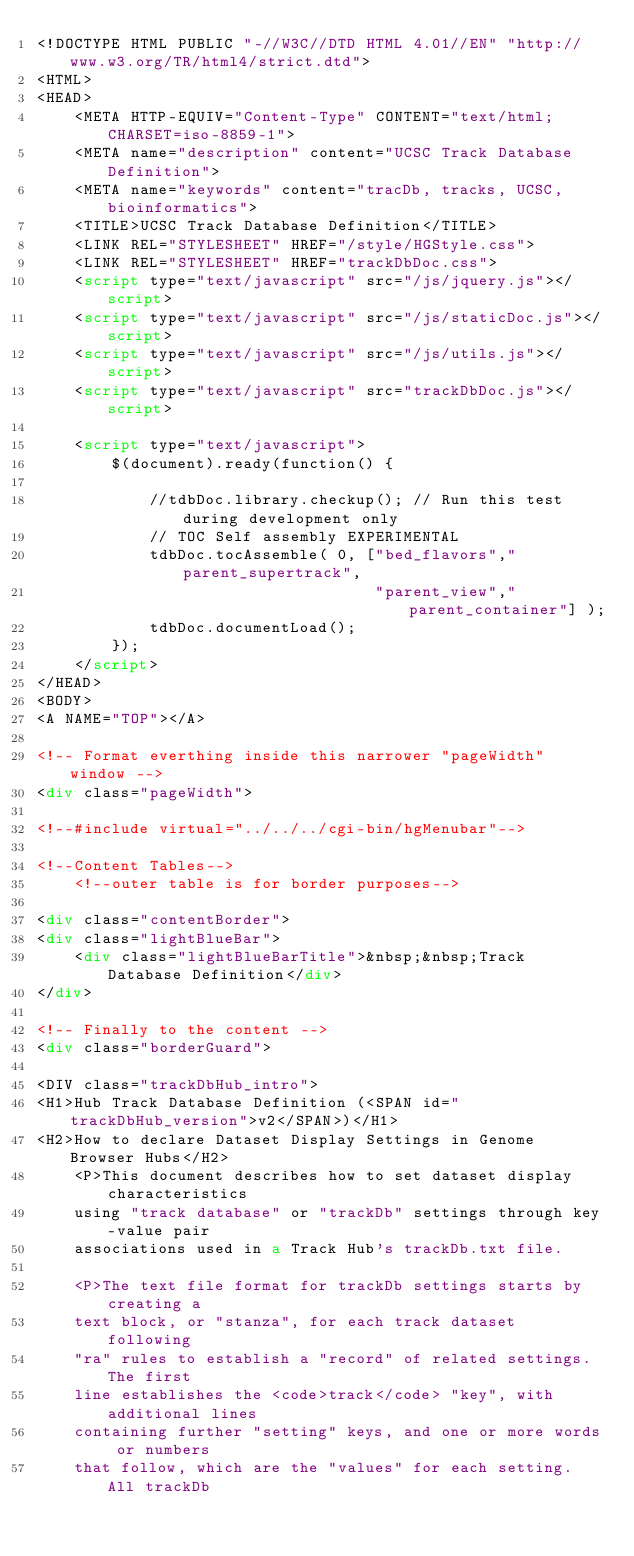Convert code to text. <code><loc_0><loc_0><loc_500><loc_500><_HTML_><!DOCTYPE HTML PUBLIC "-//W3C//DTD HTML 4.01//EN" "http://www.w3.org/TR/html4/strict.dtd">
<HTML>
<HEAD>
    <META HTTP-EQUIV="Content-Type" CONTENT="text/html;CHARSET=iso-8859-1">
    <META name="description" content="UCSC Track Database Definition">
    <META name="keywords" content="tracDb, tracks, UCSC, bioinformatics">
    <TITLE>UCSC Track Database Definition</TITLE>
    <LINK REL="STYLESHEET" HREF="/style/HGStyle.css">
    <LINK REL="STYLESHEET" HREF="trackDbDoc.css">
    <script type="text/javascript" src="/js/jquery.js"></script>
    <script type="text/javascript" src="/js/staticDoc.js"></script>
    <script type="text/javascript" src="/js/utils.js"></script>
    <script type="text/javascript" src="trackDbDoc.js"></script>

    <script type="text/javascript">
        $(document).ready(function() {

            //tdbDoc.library.checkup(); // Run this test during development only
            // TOC Self assembly EXPERIMENTAL
            tdbDoc.tocAssemble( 0, ["bed_flavors","parent_supertrack",
                                    "parent_view","parent_container"] );
            tdbDoc.documentLoad();
        });
    </script>
</HEAD>
<BODY>
<A NAME="TOP"></A>

<!-- Format everthing inside this narrower "pageWidth" window -->
<div class="pageWidth">

<!--#include virtual="../../../cgi-bin/hgMenubar"-->

<!--Content Tables-->
    <!--outer table is for border purposes-->

<div class="contentBorder">
<div class="lightBlueBar">
    <div class="lightBlueBarTitle">&nbsp;&nbsp;Track Database Definition</div>
</div>

<!-- Finally to the content -->
<div class="borderGuard">

<DIV class="trackDbHub_intro">
<H1>Hub Track Database Definition (<SPAN id="trackDbHub_version">v2</SPAN>)</H1>
<H2>How to declare Dataset Display Settings in Genome Browser Hubs</H2>
    <P>This document describes how to set dataset display characteristics
    using "track database" or "trackDb" settings through key-value pair
    associations used in a Track Hub's trackDb.txt file.

    <P>The text file format for trackDb settings starts by creating a
    text block, or "stanza", for each track dataset following
    "ra" rules to establish a "record" of related settings. The first
    line establishes the <code>track</code> "key", with additional lines
    containing further "setting" keys, and one or more words or numbers
    that follow, which are the "values" for each setting.  All trackDb</code> 